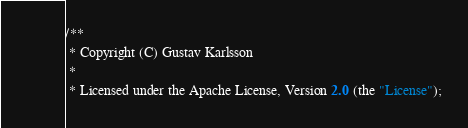<code> <loc_0><loc_0><loc_500><loc_500><_Java_>/**
 * Copyright (C) Gustav Karlsson
 *
 * Licensed under the Apache License, Version 2.0 (the "License");</code> 